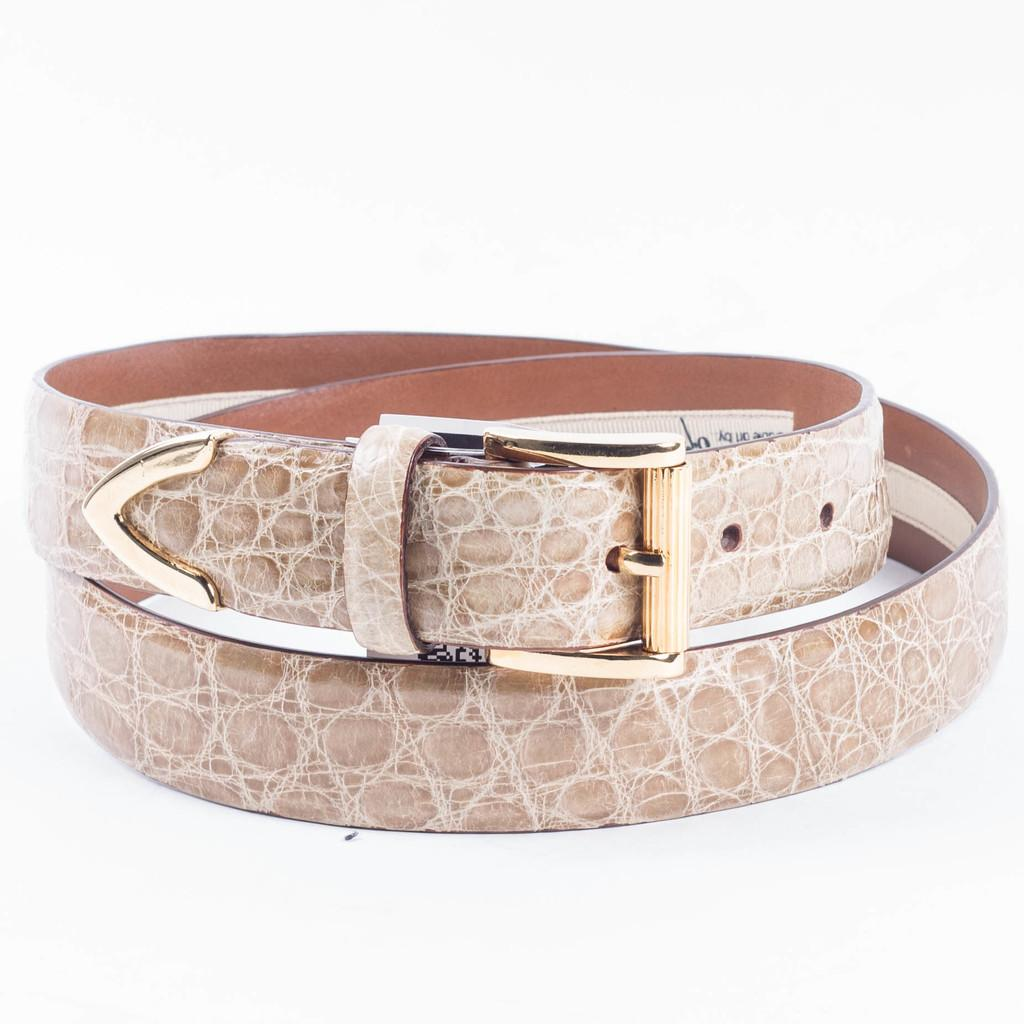What type of accessory is visible in the image? There is a leather belt in the image. What color is the background of the image? The background of the image is white. What type of button is attached to the leather belt in the image? There is no button attached to the leather belt in the image. What kind of apparatus is used to fasten the leather belt in the image? The leather belt in the image is fastened with a buckle, not an apparatus. What feeling does the leather belt evoke in the image? The image does not convey any feelings or emotions; it is a static representation of a leather belt. 